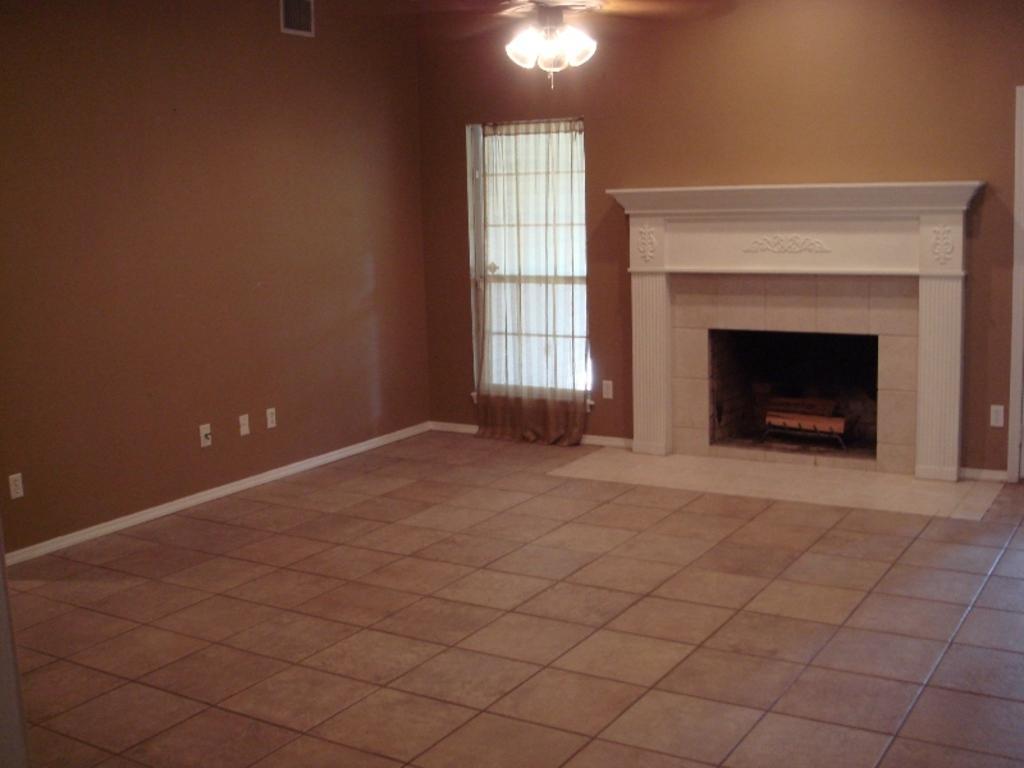Describe this image in one or two sentences. In this image we can see inside of a house. There is a window in the image. There is a curtain in the image. There are few objects on the walls. There is a lamp at the top of the image. There is a fire wood burner in the image. 